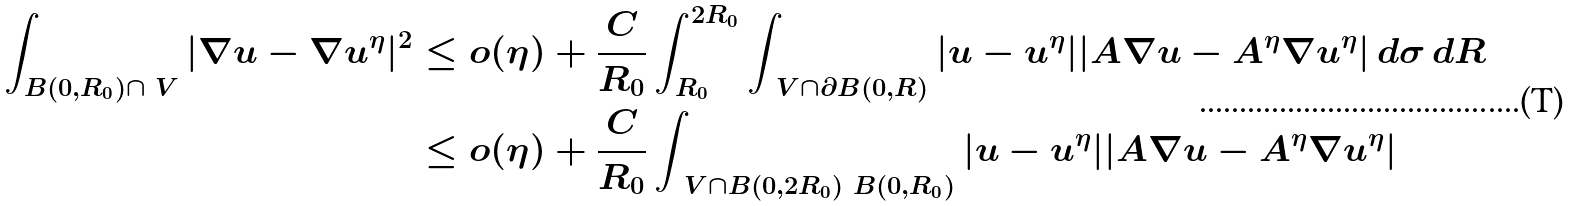<formula> <loc_0><loc_0><loc_500><loc_500>\int _ { B ( 0 , R _ { 0 } ) \cap \ V } | \nabla u - \nabla u ^ { \eta } | ^ { 2 } & \leq o ( \eta ) + \frac { C } { R _ { 0 } } \int _ { R _ { 0 } } ^ { 2 R _ { 0 } } \int _ { \ V \cap \partial B ( 0 , R ) } | u - u ^ { \eta } | | A \nabla u - A ^ { \eta } \nabla u ^ { \eta } | \, d \sigma \, d R \\ & \leq o ( \eta ) + \frac { C } { R _ { 0 } } \int _ { \ V \cap B ( 0 , 2 R _ { 0 } ) \ B ( 0 , R _ { 0 } ) } | u - u ^ { \eta } | | A \nabla u - A ^ { \eta } \nabla u ^ { \eta } |</formula> 